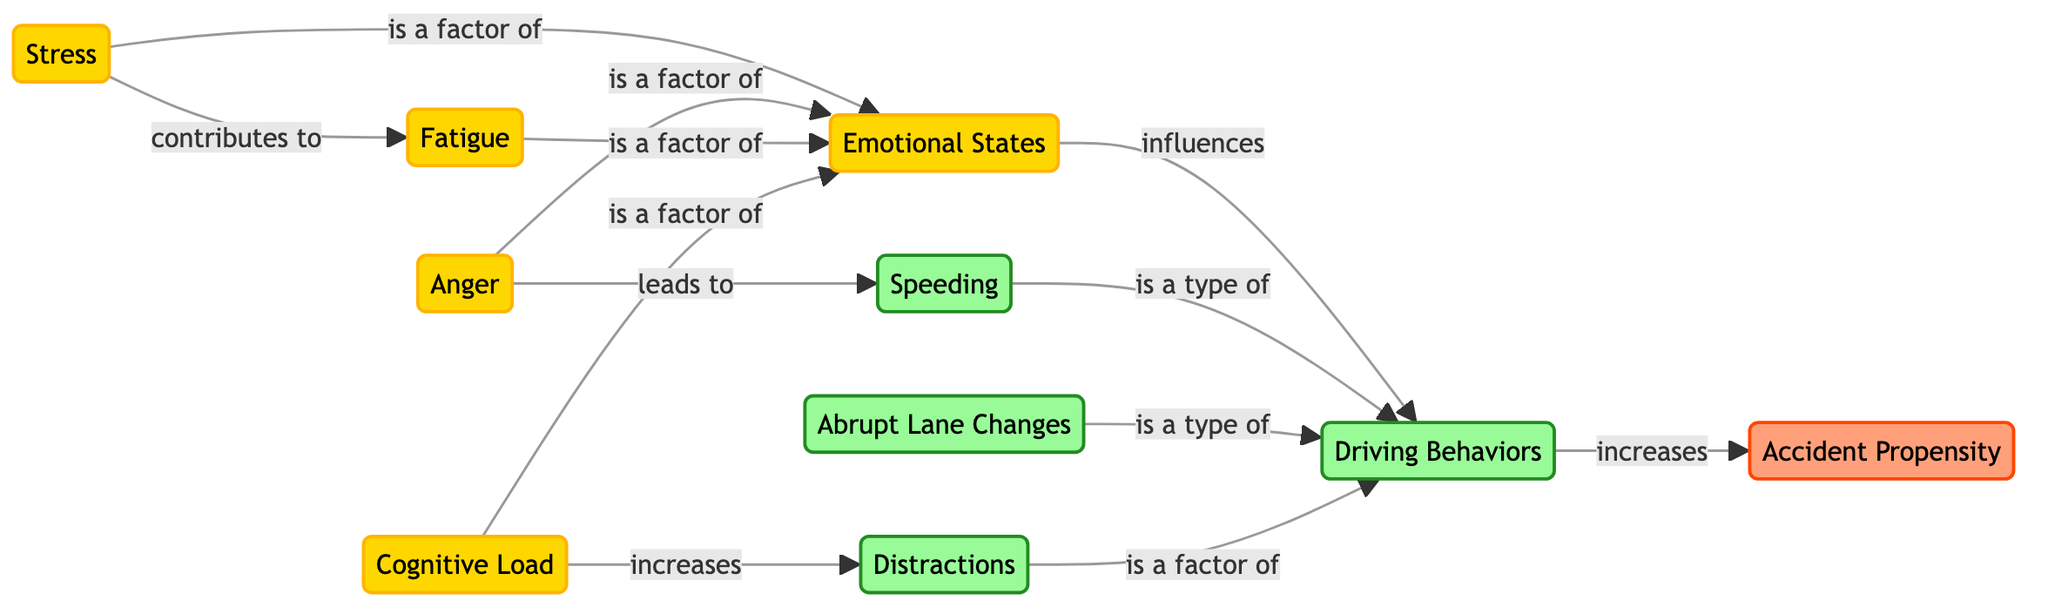What nodes are present in the diagram? The diagram contains the following nodes: Emotional States, Driving Behaviors, Accident Propensity, Stress, Anger, Fatigue, Cognitive Load, Speeding, Abrupt Lane Changes, and Distractions. Counting these, we find there are 10 nodes in total.
Answer: 10 nodes What type of relationship exists between 'Driving Behaviors' and 'Accident Propensity'? The relationship is labeled "increases," indicating that Driving Behaviors are linked to a rise in Accident Propensity. This shows a direct relationship in the flow of influence.
Answer: increases How many factors are identified under 'Emotional States'? The edges leading into the 'Emotional States' node are from Stress, Anger, Fatigue, and Cognitive Load, counting to four factors contributing to emotional states.
Answer: 4 factors What type of behavior does 'Speeding' represent? The diagram shows that Speeding is categorized as a type of Driving Behavior, specifically linked directly to the Driving Behaviors node.
Answer: is a type of Which emotional state contributes to 'Fatigue'? The diagram connects Stress to Fatigue with the label "contributes to," indicating that Stress is the emotional state that leads to an increase in Fatigue.
Answer: Stress Which emotional state leads to 'Speeding'? The diagram identifies a direct link from Anger to Speeding labeled "leads to," showing that Anger is the emotional factor contributing to higher incidences of Speeding.
Answer: Anger How does 'Cognitive Load' influence 'Distractions'? According to the diagram, Cognitive Load increases Distractions, establishing that higher levels of Cognitive Load result in a greater likelihood of Distractions while driving.
Answer: increases What is the role of 'Distractions' in the context of Driving Behaviors? The diagram indicates that Distractions are a contributing factor to Driving Behaviors, showing that they are significant in how driving is executed.
Answer: is a factor of Total how many types of Driving Behaviors are identified in the diagram? The diagram includes Speeding, Abrupt Lane Changes, and Distractions as types of Driving Behaviors, leading to a total of three distinct categories.
Answer: 3 types What comes first in the flow of influence: 'Emotional States' or 'Driving Behaviors'? The flow shows that 'Emotional States' influences the 'Driving Behaviors', meaning Emotional States come first in this influence chain.
Answer: Emotional States 